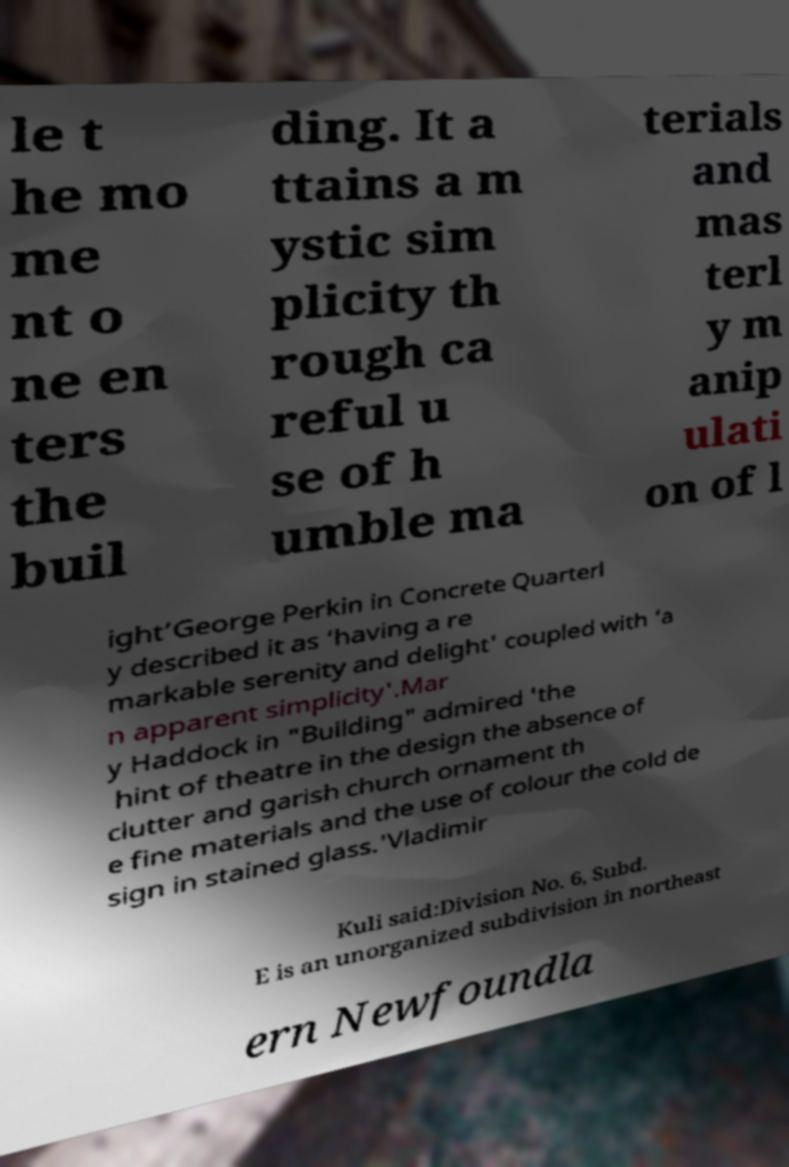For documentation purposes, I need the text within this image transcribed. Could you provide that? le t he mo me nt o ne en ters the buil ding. It a ttains a m ystic sim plicity th rough ca reful u se of h umble ma terials and mas terl y m anip ulati on of l ight’George Perkin in Concrete Quarterl y described it as ‘having a re markable serenity and delight' coupled with ‘a n apparent simplicity'.Mar y Haddock in "Building" admired 'the hint of theatre in the design the absence of clutter and garish church ornament th e fine materials and the use of colour the cold de sign in stained glass.'Vladimir Kuli said:Division No. 6, Subd. E is an unorganized subdivision in northeast ern Newfoundla 